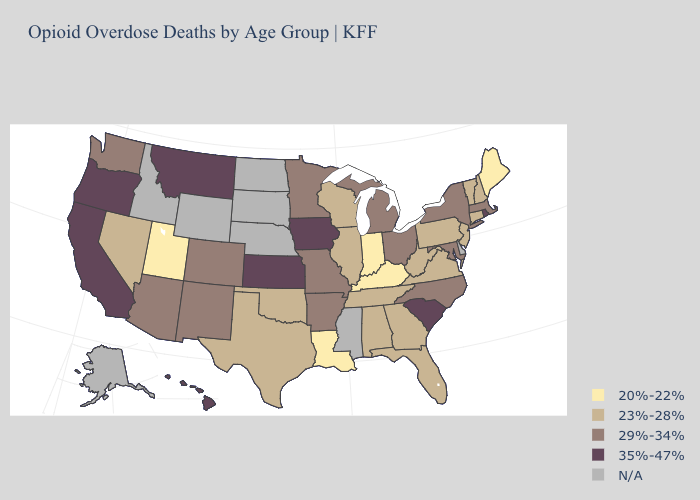Which states have the highest value in the USA?
Keep it brief. California, Hawaii, Iowa, Kansas, Montana, Oregon, Rhode Island, South Carolina. Name the states that have a value in the range 29%-34%?
Concise answer only. Arizona, Arkansas, Colorado, Maryland, Massachusetts, Michigan, Minnesota, Missouri, New Mexico, New York, North Carolina, Ohio, Washington. Name the states that have a value in the range N/A?
Concise answer only. Alaska, Delaware, Idaho, Mississippi, Nebraska, North Dakota, South Dakota, Wyoming. What is the highest value in the South ?
Answer briefly. 35%-47%. What is the value of North Dakota?
Concise answer only. N/A. Which states have the highest value in the USA?
Be succinct. California, Hawaii, Iowa, Kansas, Montana, Oregon, Rhode Island, South Carolina. Which states have the highest value in the USA?
Write a very short answer. California, Hawaii, Iowa, Kansas, Montana, Oregon, Rhode Island, South Carolina. What is the lowest value in the USA?
Quick response, please. 20%-22%. Name the states that have a value in the range 29%-34%?
Answer briefly. Arizona, Arkansas, Colorado, Maryland, Massachusetts, Michigan, Minnesota, Missouri, New Mexico, New York, North Carolina, Ohio, Washington. What is the value of South Carolina?
Answer briefly. 35%-47%. Name the states that have a value in the range 35%-47%?
Short answer required. California, Hawaii, Iowa, Kansas, Montana, Oregon, Rhode Island, South Carolina. Name the states that have a value in the range 20%-22%?
Be succinct. Indiana, Kentucky, Louisiana, Maine, Utah. Name the states that have a value in the range 23%-28%?
Be succinct. Alabama, Connecticut, Florida, Georgia, Illinois, Nevada, New Hampshire, New Jersey, Oklahoma, Pennsylvania, Tennessee, Texas, Vermont, Virginia, West Virginia, Wisconsin. 